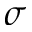Convert formula to latex. <formula><loc_0><loc_0><loc_500><loc_500>\sigma</formula> 